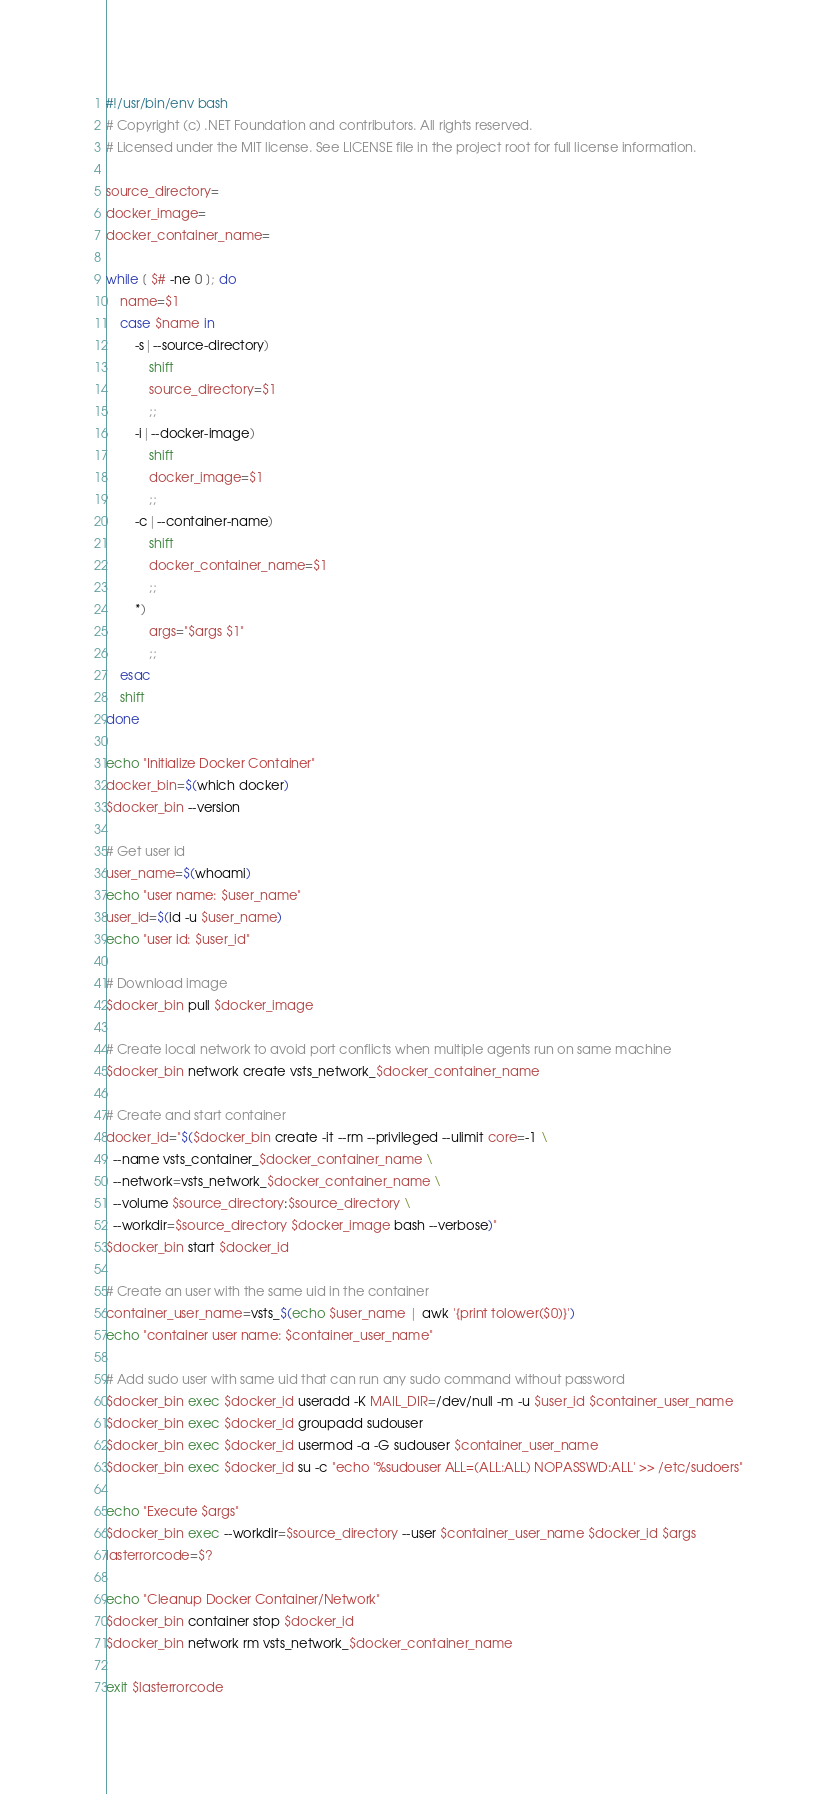Convert code to text. <code><loc_0><loc_0><loc_500><loc_500><_Bash_>#!/usr/bin/env bash
# Copyright (c) .NET Foundation and contributors. All rights reserved.
# Licensed under the MIT license. See LICENSE file in the project root for full license information.

source_directory=
docker_image=
docker_container_name=

while [ $# -ne 0 ]; do
    name=$1
    case $name in
        -s|--source-directory)
            shift
            source_directory=$1
            ;;
        -i|--docker-image)
            shift
            docker_image=$1
            ;;
        -c|--container-name)
            shift
            docker_container_name=$1
            ;;
        *)
            args="$args $1"
            ;;
    esac
    shift
done

echo "Initialize Docker Container"
docker_bin=$(which docker)
$docker_bin --version

# Get user id
user_name=$(whoami)
echo "user name: $user_name"
user_id=$(id -u $user_name)
echo "user id: $user_id"

# Download image
$docker_bin pull $docker_image

# Create local network to avoid port conflicts when multiple agents run on same machine
$docker_bin network create vsts_network_$docker_container_name

# Create and start container
docker_id="$($docker_bin create -it --rm --privileged --ulimit core=-1 \
  --name vsts_container_$docker_container_name \
  --network=vsts_network_$docker_container_name \
  --volume $source_directory:$source_directory \
  --workdir=$source_directory $docker_image bash --verbose)"
$docker_bin start $docker_id

# Create an user with the same uid in the container
container_user_name=vsts_$(echo $user_name | awk '{print tolower($0)}')
echo "container user name: $container_user_name"

# Add sudo user with same uid that can run any sudo command without password
$docker_bin exec $docker_id useradd -K MAIL_DIR=/dev/null -m -u $user_id $container_user_name
$docker_bin exec $docker_id groupadd sudouser
$docker_bin exec $docker_id usermod -a -G sudouser $container_user_name
$docker_bin exec $docker_id su -c "echo '%sudouser ALL=(ALL:ALL) NOPASSWD:ALL' >> /etc/sudoers"

echo "Execute $args"
$docker_bin exec --workdir=$source_directory --user $container_user_name $docker_id $args
lasterrorcode=$?

echo "Cleanup Docker Container/Network"
$docker_bin container stop $docker_id
$docker_bin network rm vsts_network_$docker_container_name

exit $lasterrorcode

</code> 